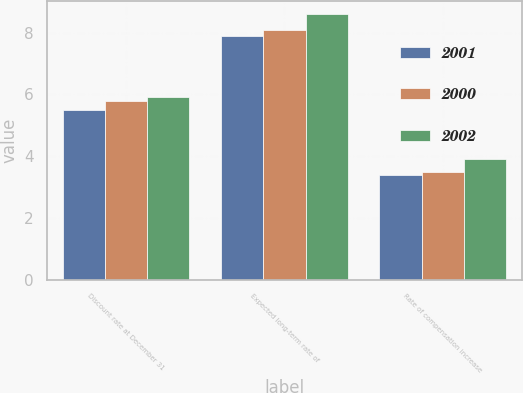Convert chart to OTSL. <chart><loc_0><loc_0><loc_500><loc_500><stacked_bar_chart><ecel><fcel>Discount rate at December 31<fcel>Expected long-term rate of<fcel>Rate of compensation increase<nl><fcel>2001<fcel>5.5<fcel>7.9<fcel>3.4<nl><fcel>2000<fcel>5.8<fcel>8.1<fcel>3.5<nl><fcel>2002<fcel>5.9<fcel>8.6<fcel>3.9<nl></chart> 